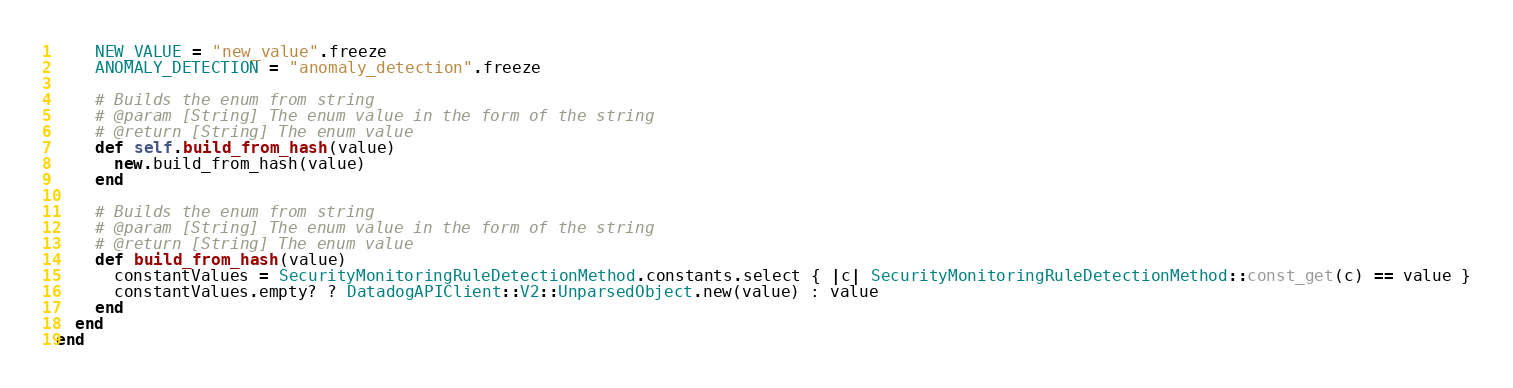Convert code to text. <code><loc_0><loc_0><loc_500><loc_500><_Ruby_>    NEW_VALUE = "new_value".freeze
    ANOMALY_DETECTION = "anomaly_detection".freeze

    # Builds the enum from string
    # @param [String] The enum value in the form of the string
    # @return [String] The enum value
    def self.build_from_hash(value)
      new.build_from_hash(value)
    end

    # Builds the enum from string
    # @param [String] The enum value in the form of the string
    # @return [String] The enum value
    def build_from_hash(value)
      constantValues = SecurityMonitoringRuleDetectionMethod.constants.select { |c| SecurityMonitoringRuleDetectionMethod::const_get(c) == value }
      constantValues.empty? ? DatadogAPIClient::V2::UnparsedObject.new(value) : value
    end
  end
end
</code> 